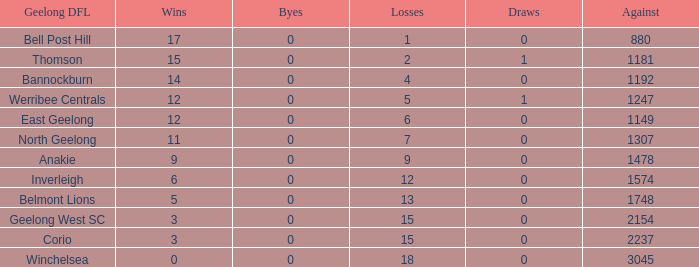What is the total number of losses where the byes were greater than 0? 0.0. 